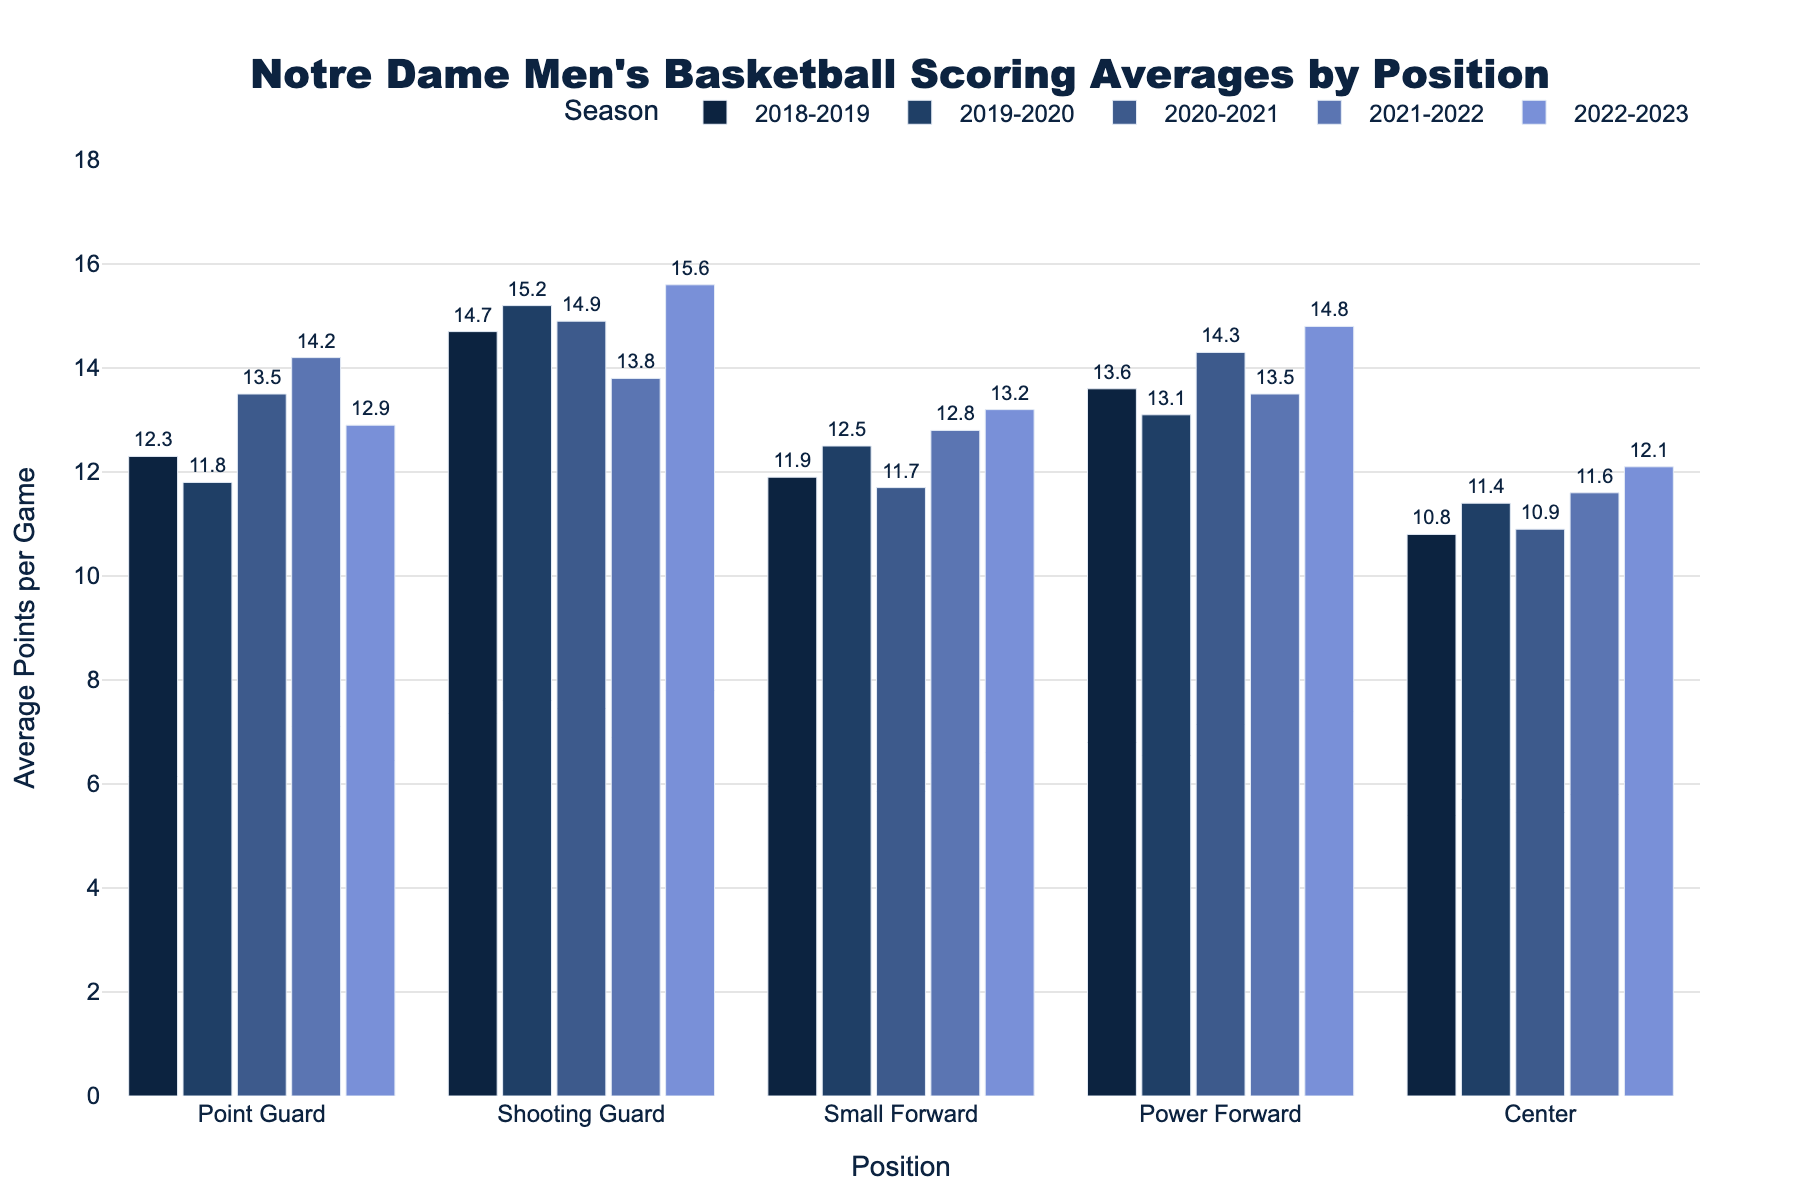Which position had the highest scoring average in the 2022-2023 season? Look at the heights of the bars marked for the 2022-2023 season. The highest bar will indicate the position with the highest scoring average.
Answer: Shooting Guard What is the combined scoring average of Small Forward and Center in the 2020-2021 season? To find the combined scoring average, add the average points per game for Small Forward and Center in the 2020-2021 season (11.7 + 10.9).
Answer: 22.6 How did the scoring average for Point Guard change between the 2018-2019 and 2021-2022 seasons? Subtract the Point Guard's scoring average in the 2018-2019 season (12.3) from the average in the 2021-2022 season (14.2). The result gives the change in scoring average.
Answer: 1.9 increase Which position showed the most consistent scoring average over the five seasons, based on visual inspection of the bar heights? By visually comparing the heights of bars across all seasons, the position with the least variation in bar heights will be the most consistent.
Answer: Center Rank the positions from highest to lowest scoring average in the 2019-2020 season. Compare the heights of bars for each position within the 2019-2020 season and list them from highest to lowest.
Answer: Shooting Guard, Power Forward, Small Forward, Point Guard, Center Was there any position whose scoring average decreased in the 2022-2023 season compared to the previous season? Compare each position's 2022-2023 scoring average to its 2021-2022 average. Look for any instance where the 2022-2023 value is lower.
Answer: Point Guard Which season had the highest scoring average across all positions combined? Sum the scoring averages for all positions for each season and then compare these sums to determine the highest.
Answer: 2019-2020 What is the average scoring average of the Shooting Guard over the five seasons? Add the scoring averages of the Shooting Guard for all 5 seasons (14.7 + 15.2 + 14.9 + 13.8 + 15.6) and divide by 5.
Answer: 14.84 Is there any position that had its highest scoring average in the same year? If yes, which and when? Examine each position to see if their highest bar (scoring average) aligns in the same year for all.
Answer: No Which position had the lowest scoring average in the 2018-2019 season? Look at the heights of the bars for the 2018-2019 season and identify the lowest one.
Answer: Center 